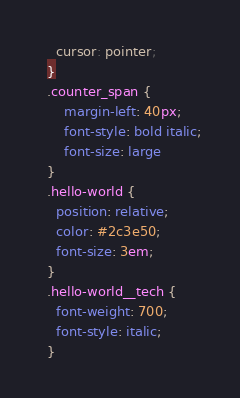Convert code to text. <code><loc_0><loc_0><loc_500><loc_500><_CSS_>    cursor: pointer;
  }
  .counter_span {
      margin-left: 40px;
      font-style: bold italic;
      font-size: large
  }
  .hello-world {
    position: relative;
    color: #2c3e50;
    font-size: 3em;
  }
  .hello-world__tech {
    font-weight: 700;
    font-style: italic;
  }</code> 